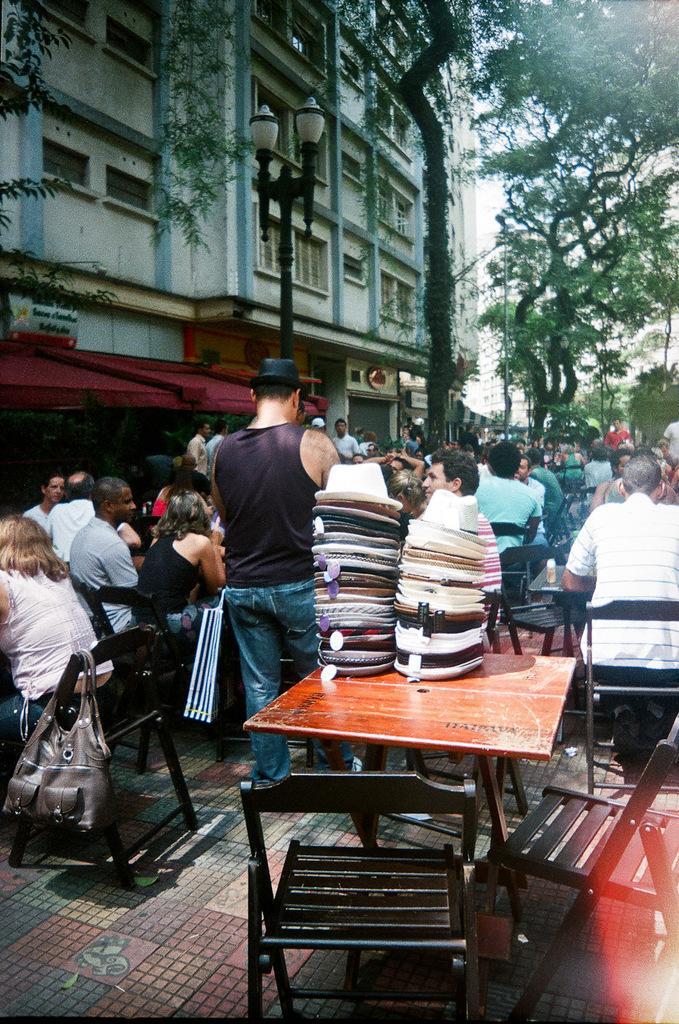Describe this image in one or two sentences. This picture is clicked outside the city. Here, we see many people sitting on chair. In front of picture, we see a table on which many hats are placed. On background, we see buildings and trees and we even see street lights in the middle of this picture. 